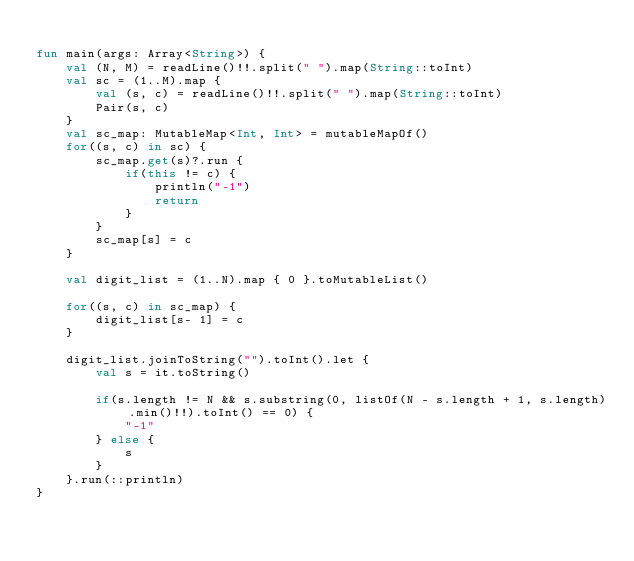Convert code to text. <code><loc_0><loc_0><loc_500><loc_500><_Kotlin_>
fun main(args: Array<String>) {
    val (N, M) = readLine()!!.split(" ").map(String::toInt)
    val sc = (1..M).map {
        val (s, c) = readLine()!!.split(" ").map(String::toInt)
        Pair(s, c)
    }
    val sc_map: MutableMap<Int, Int> = mutableMapOf()
    for((s, c) in sc) {
        sc_map.get(s)?.run {
            if(this != c) {
                println("-1")
                return
            }
        }
        sc_map[s] = c
    }

    val digit_list = (1..N).map { 0 }.toMutableList()
    
    for((s, c) in sc_map) {
        digit_list[s- 1] = c
    }

    digit_list.joinToString("").toInt().let {
        val s = it.toString()
    
        if(s.length != N && s.substring(0, listOf(N - s.length + 1, s.length).min()!!).toInt() == 0) {
            "-1"
        } else {
            s
        }
    }.run(::println)
}</code> 